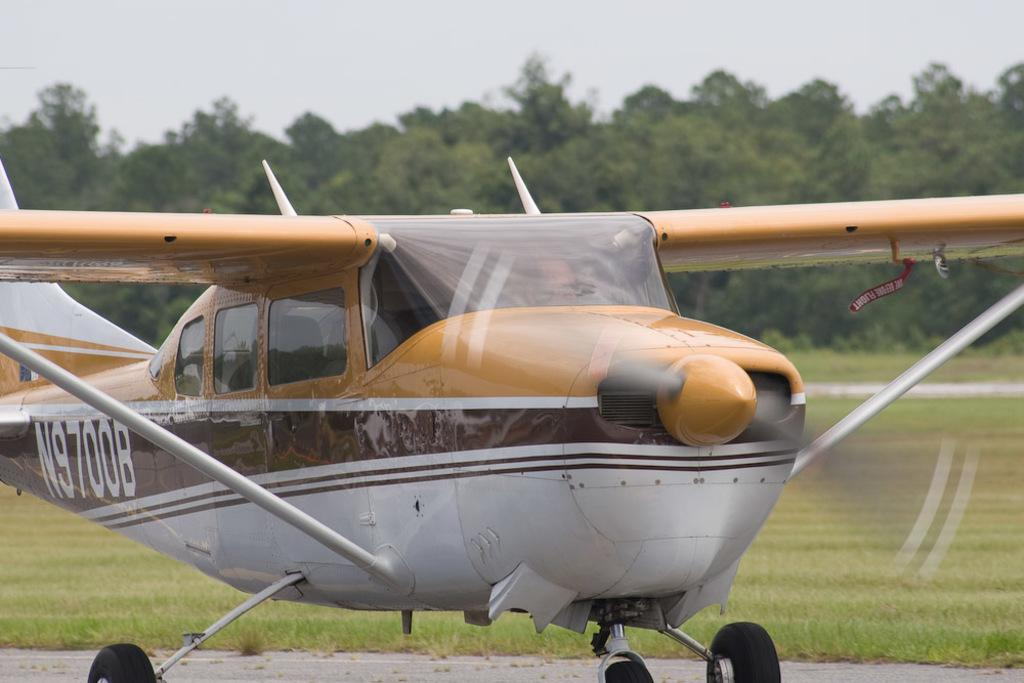<image>
Provide a brief description of the given image. A plane has the numbers N9700B on the side. 